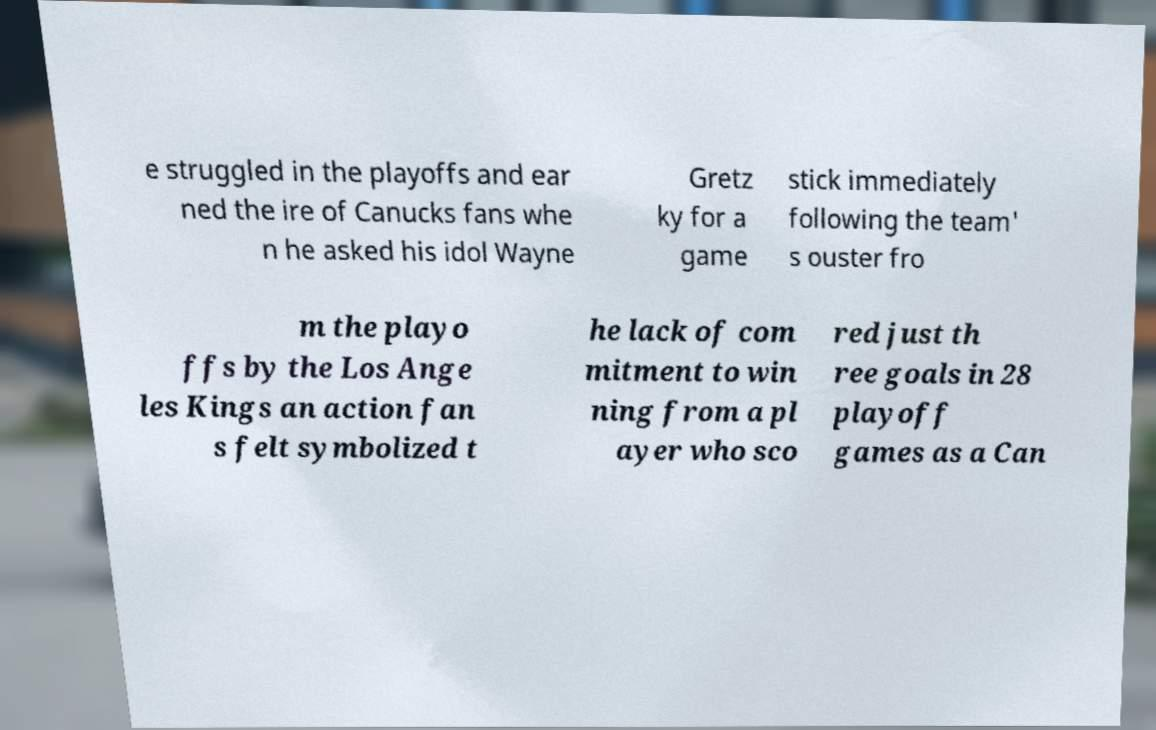What messages or text are displayed in this image? I need them in a readable, typed format. e struggled in the playoffs and ear ned the ire of Canucks fans whe n he asked his idol Wayne Gretz ky for a game stick immediately following the team' s ouster fro m the playo ffs by the Los Ange les Kings an action fan s felt symbolized t he lack of com mitment to win ning from a pl ayer who sco red just th ree goals in 28 playoff games as a Can 